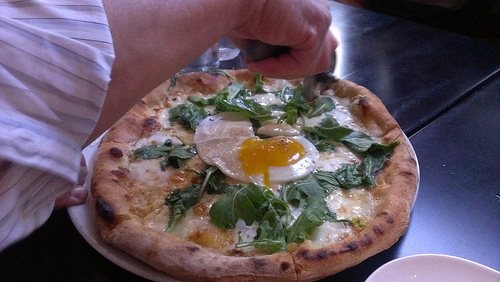Can you describe the dish in detail? The dish appears to be a gourmet pizza. It has a thin, slightly charred crust with a golden brown edge. The pizza is topped with fresh spinach leaves scattered around. At the center of the pizza is a perfectly cooked egg with a runny yolk, surrounded by melted cheese. It looks like a delicious and visually appealing combination of ingredients. 